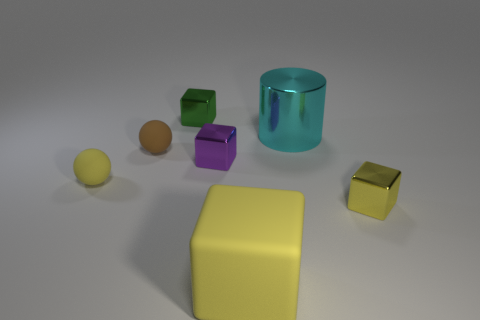Does the small yellow object to the left of the green object have the same material as the big block?
Provide a short and direct response. Yes. Does the matte block have the same color as the small shiny thing that is behind the big cyan object?
Provide a succinct answer. No. Are there any tiny yellow objects left of the purple metallic object?
Provide a succinct answer. Yes. Do the rubber thing on the left side of the brown object and the yellow matte thing right of the brown sphere have the same size?
Provide a succinct answer. No. Are there any metallic cubes of the same size as the cyan metal cylinder?
Offer a very short reply. No. Is the shape of the small green metal object behind the cyan metal thing the same as  the small yellow metal thing?
Offer a terse response. Yes. There is a yellow object on the right side of the big cyan metal thing; what is it made of?
Offer a very short reply. Metal. There is a small shiny object right of the large thing behind the small purple thing; what is its shape?
Your answer should be very brief. Cube. Do the large yellow thing and the small shiny thing that is behind the tiny brown rubber thing have the same shape?
Provide a short and direct response. Yes. There is a yellow matte thing on the left side of the green metal object; what number of cylinders are in front of it?
Provide a succinct answer. 0. 